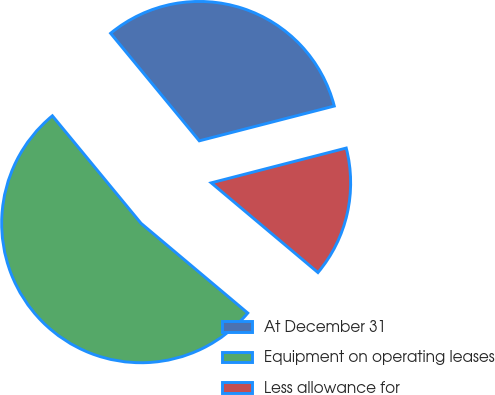Convert chart. <chart><loc_0><loc_0><loc_500><loc_500><pie_chart><fcel>At December 31<fcel>Equipment on operating leases<fcel>Less allowance for<nl><fcel>31.96%<fcel>52.9%<fcel>15.14%<nl></chart> 